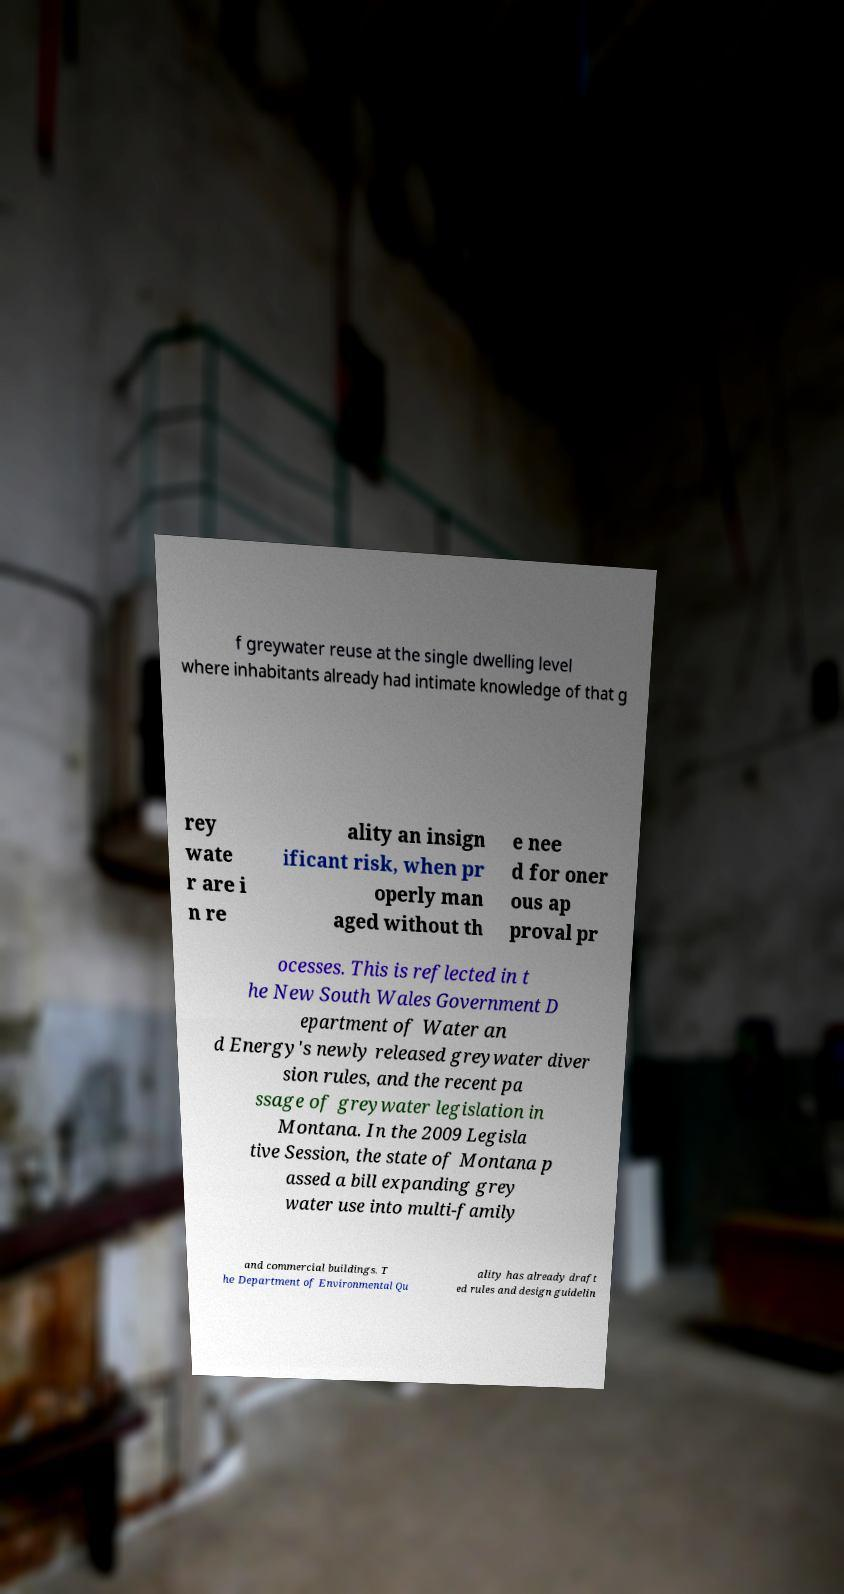Can you accurately transcribe the text from the provided image for me? f greywater reuse at the single dwelling level where inhabitants already had intimate knowledge of that g rey wate r are i n re ality an insign ificant risk, when pr operly man aged without th e nee d for oner ous ap proval pr ocesses. This is reflected in t he New South Wales Government D epartment of Water an d Energy's newly released greywater diver sion rules, and the recent pa ssage of greywater legislation in Montana. In the 2009 Legisla tive Session, the state of Montana p assed a bill expanding grey water use into multi-family and commercial buildings. T he Department of Environmental Qu ality has already draft ed rules and design guidelin 